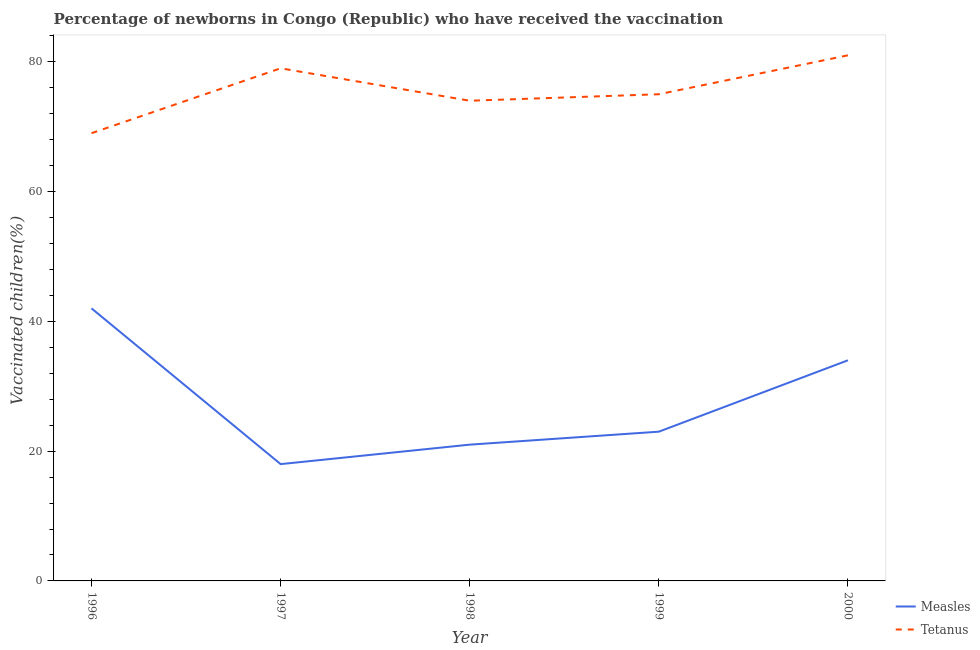How many different coloured lines are there?
Offer a terse response. 2. Is the number of lines equal to the number of legend labels?
Offer a very short reply. Yes. What is the percentage of newborns who received vaccination for measles in 2000?
Your response must be concise. 34. Across all years, what is the maximum percentage of newborns who received vaccination for measles?
Ensure brevity in your answer.  42. Across all years, what is the minimum percentage of newborns who received vaccination for measles?
Provide a succinct answer. 18. In which year was the percentage of newborns who received vaccination for measles maximum?
Offer a terse response. 1996. In which year was the percentage of newborns who received vaccination for tetanus minimum?
Offer a terse response. 1996. What is the total percentage of newborns who received vaccination for tetanus in the graph?
Your answer should be compact. 378. What is the difference between the percentage of newborns who received vaccination for measles in 1998 and that in 1999?
Provide a succinct answer. -2. What is the difference between the percentage of newborns who received vaccination for measles in 1996 and the percentage of newborns who received vaccination for tetanus in 1998?
Your response must be concise. -32. What is the average percentage of newborns who received vaccination for tetanus per year?
Ensure brevity in your answer.  75.6. In the year 1997, what is the difference between the percentage of newborns who received vaccination for tetanus and percentage of newborns who received vaccination for measles?
Give a very brief answer. 61. What is the ratio of the percentage of newborns who received vaccination for measles in 1996 to that in 1999?
Give a very brief answer. 1.83. Is the difference between the percentage of newborns who received vaccination for tetanus in 1997 and 1999 greater than the difference between the percentage of newborns who received vaccination for measles in 1997 and 1999?
Offer a terse response. Yes. What is the difference between the highest and the lowest percentage of newborns who received vaccination for tetanus?
Make the answer very short. 12. In how many years, is the percentage of newborns who received vaccination for measles greater than the average percentage of newborns who received vaccination for measles taken over all years?
Your answer should be very brief. 2. Does the percentage of newborns who received vaccination for measles monotonically increase over the years?
Your answer should be very brief. No. Is the percentage of newborns who received vaccination for measles strictly greater than the percentage of newborns who received vaccination for tetanus over the years?
Keep it short and to the point. No. Is the percentage of newborns who received vaccination for tetanus strictly less than the percentage of newborns who received vaccination for measles over the years?
Your answer should be very brief. No. How many lines are there?
Offer a very short reply. 2. Does the graph contain any zero values?
Your answer should be compact. No. What is the title of the graph?
Your answer should be very brief. Percentage of newborns in Congo (Republic) who have received the vaccination. What is the label or title of the X-axis?
Ensure brevity in your answer.  Year. What is the label or title of the Y-axis?
Make the answer very short. Vaccinated children(%)
. What is the Vaccinated children(%)
 of Measles in 1996?
Give a very brief answer. 42. What is the Vaccinated children(%)
 in Tetanus in 1996?
Give a very brief answer. 69. What is the Vaccinated children(%)
 in Tetanus in 1997?
Your answer should be compact. 79. What is the Vaccinated children(%)
 in Measles in 1998?
Give a very brief answer. 21. What is the Vaccinated children(%)
 in Tetanus in 1998?
Provide a succinct answer. 74. What is the Vaccinated children(%)
 of Measles in 1999?
Provide a short and direct response. 23. Across all years, what is the maximum Vaccinated children(%)
 of Tetanus?
Keep it short and to the point. 81. Across all years, what is the minimum Vaccinated children(%)
 of Tetanus?
Your answer should be very brief. 69. What is the total Vaccinated children(%)
 of Measles in the graph?
Provide a succinct answer. 138. What is the total Vaccinated children(%)
 in Tetanus in the graph?
Offer a very short reply. 378. What is the difference between the Vaccinated children(%)
 in Measles in 1996 and that in 1997?
Your answer should be very brief. 24. What is the difference between the Vaccinated children(%)
 in Tetanus in 1996 and that in 1997?
Provide a succinct answer. -10. What is the difference between the Vaccinated children(%)
 in Measles in 1996 and that in 1998?
Give a very brief answer. 21. What is the difference between the Vaccinated children(%)
 of Tetanus in 1996 and that in 1998?
Make the answer very short. -5. What is the difference between the Vaccinated children(%)
 in Measles in 1996 and that in 1999?
Provide a succinct answer. 19. What is the difference between the Vaccinated children(%)
 of Tetanus in 1996 and that in 1999?
Offer a terse response. -6. What is the difference between the Vaccinated children(%)
 in Measles in 1997 and that in 1998?
Offer a terse response. -3. What is the difference between the Vaccinated children(%)
 of Tetanus in 1997 and that in 1998?
Offer a very short reply. 5. What is the difference between the Vaccinated children(%)
 of Measles in 1997 and that in 1999?
Your answer should be very brief. -5. What is the difference between the Vaccinated children(%)
 in Tetanus in 1997 and that in 2000?
Keep it short and to the point. -2. What is the difference between the Vaccinated children(%)
 of Tetanus in 1998 and that in 1999?
Offer a terse response. -1. What is the difference between the Vaccinated children(%)
 of Measles in 1998 and that in 2000?
Provide a succinct answer. -13. What is the difference between the Vaccinated children(%)
 of Measles in 1999 and that in 2000?
Keep it short and to the point. -11. What is the difference between the Vaccinated children(%)
 of Measles in 1996 and the Vaccinated children(%)
 of Tetanus in 1997?
Provide a short and direct response. -37. What is the difference between the Vaccinated children(%)
 in Measles in 1996 and the Vaccinated children(%)
 in Tetanus in 1998?
Offer a terse response. -32. What is the difference between the Vaccinated children(%)
 of Measles in 1996 and the Vaccinated children(%)
 of Tetanus in 1999?
Your response must be concise. -33. What is the difference between the Vaccinated children(%)
 of Measles in 1996 and the Vaccinated children(%)
 of Tetanus in 2000?
Your answer should be very brief. -39. What is the difference between the Vaccinated children(%)
 of Measles in 1997 and the Vaccinated children(%)
 of Tetanus in 1998?
Offer a very short reply. -56. What is the difference between the Vaccinated children(%)
 in Measles in 1997 and the Vaccinated children(%)
 in Tetanus in 1999?
Your answer should be very brief. -57. What is the difference between the Vaccinated children(%)
 in Measles in 1997 and the Vaccinated children(%)
 in Tetanus in 2000?
Your answer should be very brief. -63. What is the difference between the Vaccinated children(%)
 of Measles in 1998 and the Vaccinated children(%)
 of Tetanus in 1999?
Your answer should be very brief. -54. What is the difference between the Vaccinated children(%)
 of Measles in 1998 and the Vaccinated children(%)
 of Tetanus in 2000?
Provide a short and direct response. -60. What is the difference between the Vaccinated children(%)
 of Measles in 1999 and the Vaccinated children(%)
 of Tetanus in 2000?
Your answer should be very brief. -58. What is the average Vaccinated children(%)
 of Measles per year?
Ensure brevity in your answer.  27.6. What is the average Vaccinated children(%)
 in Tetanus per year?
Your response must be concise. 75.6. In the year 1996, what is the difference between the Vaccinated children(%)
 of Measles and Vaccinated children(%)
 of Tetanus?
Offer a very short reply. -27. In the year 1997, what is the difference between the Vaccinated children(%)
 in Measles and Vaccinated children(%)
 in Tetanus?
Keep it short and to the point. -61. In the year 1998, what is the difference between the Vaccinated children(%)
 of Measles and Vaccinated children(%)
 of Tetanus?
Make the answer very short. -53. In the year 1999, what is the difference between the Vaccinated children(%)
 in Measles and Vaccinated children(%)
 in Tetanus?
Ensure brevity in your answer.  -52. In the year 2000, what is the difference between the Vaccinated children(%)
 in Measles and Vaccinated children(%)
 in Tetanus?
Ensure brevity in your answer.  -47. What is the ratio of the Vaccinated children(%)
 in Measles in 1996 to that in 1997?
Give a very brief answer. 2.33. What is the ratio of the Vaccinated children(%)
 of Tetanus in 1996 to that in 1997?
Ensure brevity in your answer.  0.87. What is the ratio of the Vaccinated children(%)
 in Measles in 1996 to that in 1998?
Your answer should be compact. 2. What is the ratio of the Vaccinated children(%)
 of Tetanus in 1996 to that in 1998?
Offer a very short reply. 0.93. What is the ratio of the Vaccinated children(%)
 of Measles in 1996 to that in 1999?
Provide a succinct answer. 1.83. What is the ratio of the Vaccinated children(%)
 in Tetanus in 1996 to that in 1999?
Your answer should be very brief. 0.92. What is the ratio of the Vaccinated children(%)
 of Measles in 1996 to that in 2000?
Provide a short and direct response. 1.24. What is the ratio of the Vaccinated children(%)
 of Tetanus in 1996 to that in 2000?
Keep it short and to the point. 0.85. What is the ratio of the Vaccinated children(%)
 of Measles in 1997 to that in 1998?
Provide a succinct answer. 0.86. What is the ratio of the Vaccinated children(%)
 of Tetanus in 1997 to that in 1998?
Give a very brief answer. 1.07. What is the ratio of the Vaccinated children(%)
 of Measles in 1997 to that in 1999?
Give a very brief answer. 0.78. What is the ratio of the Vaccinated children(%)
 of Tetanus in 1997 to that in 1999?
Offer a terse response. 1.05. What is the ratio of the Vaccinated children(%)
 in Measles in 1997 to that in 2000?
Offer a terse response. 0.53. What is the ratio of the Vaccinated children(%)
 in Tetanus in 1997 to that in 2000?
Your answer should be very brief. 0.98. What is the ratio of the Vaccinated children(%)
 of Tetanus in 1998 to that in 1999?
Offer a terse response. 0.99. What is the ratio of the Vaccinated children(%)
 of Measles in 1998 to that in 2000?
Ensure brevity in your answer.  0.62. What is the ratio of the Vaccinated children(%)
 of Tetanus in 1998 to that in 2000?
Keep it short and to the point. 0.91. What is the ratio of the Vaccinated children(%)
 in Measles in 1999 to that in 2000?
Provide a short and direct response. 0.68. What is the ratio of the Vaccinated children(%)
 in Tetanus in 1999 to that in 2000?
Provide a short and direct response. 0.93. What is the difference between the highest and the second highest Vaccinated children(%)
 of Tetanus?
Ensure brevity in your answer.  2. What is the difference between the highest and the lowest Vaccinated children(%)
 in Measles?
Make the answer very short. 24. 